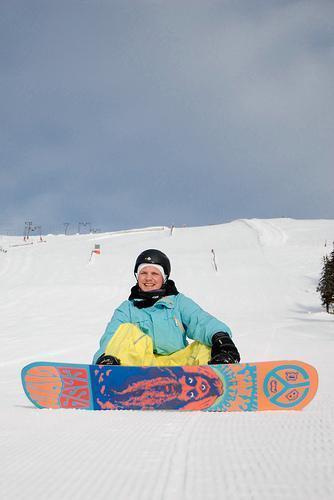How many people?
Give a very brief answer. 1. 